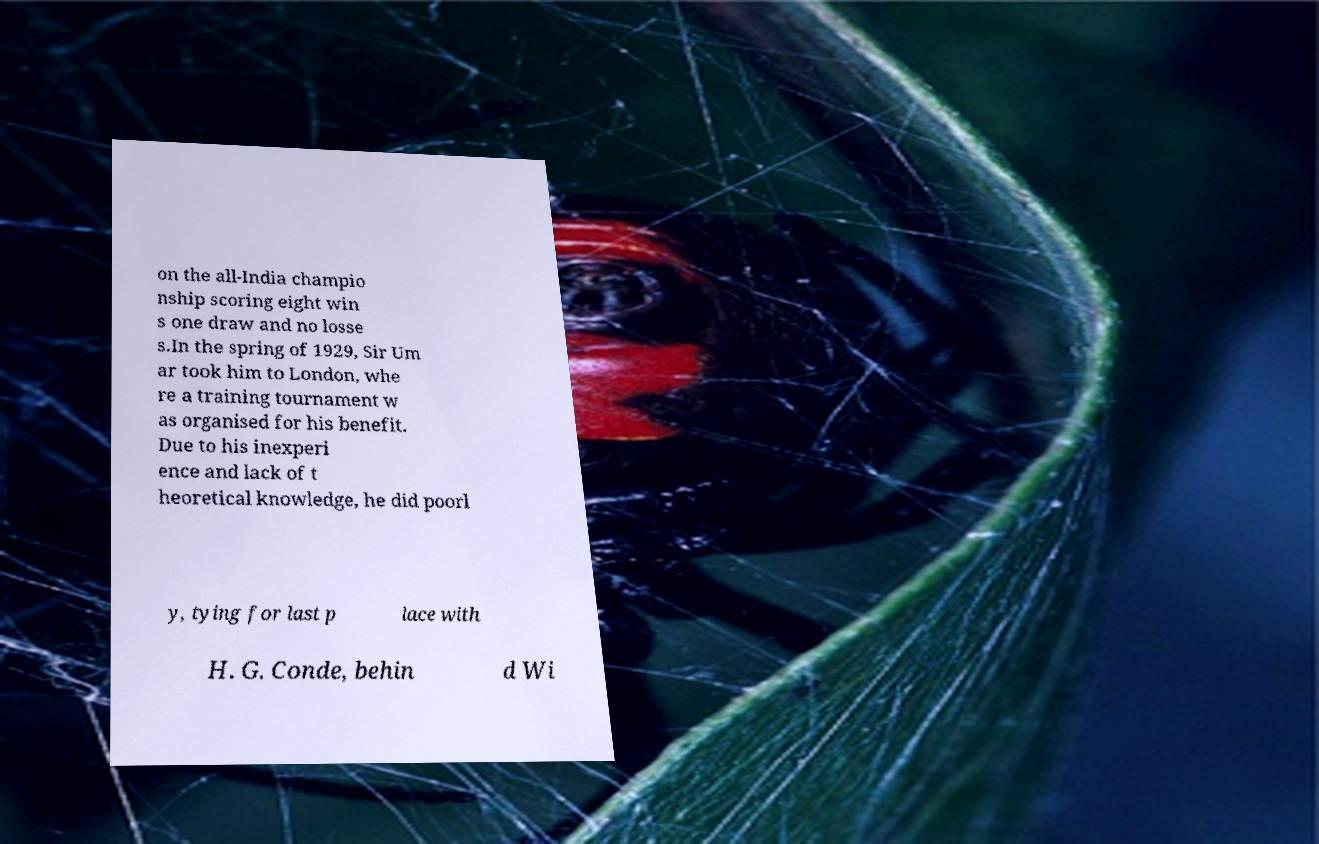Could you assist in decoding the text presented in this image and type it out clearly? on the all-India champio nship scoring eight win s one draw and no losse s.In the spring of 1929, Sir Um ar took him to London, whe re a training tournament w as organised for his benefit. Due to his inexperi ence and lack of t heoretical knowledge, he did poorl y, tying for last p lace with H. G. Conde, behin d Wi 